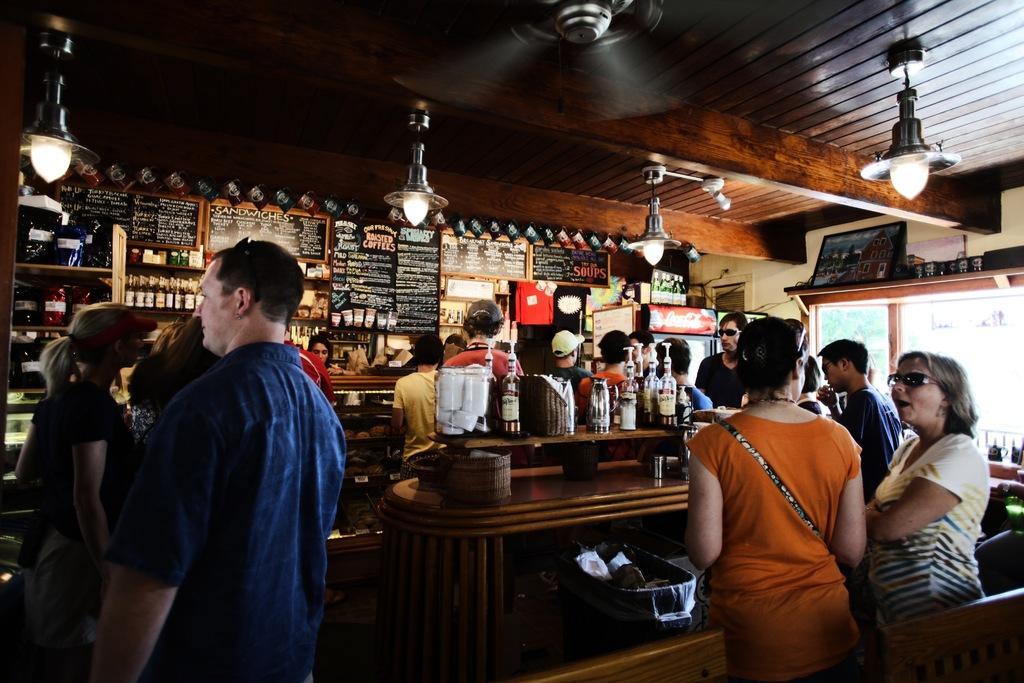Please provide a concise description of this image. This image is clicked inside park, there are many peoples standing on either side of the table with wine bottles on it, in the back there are menu boards on the wall with racks in front of it with bottles in it, there are lights over the ceiling with a fan in the middle. 